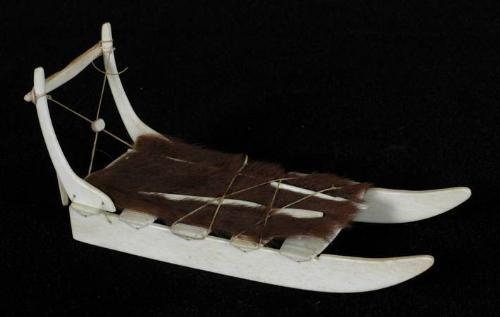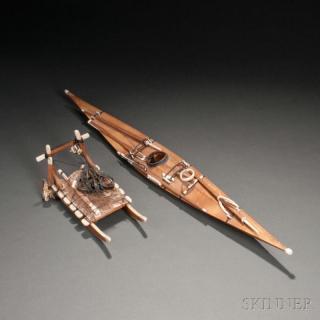The first image is the image on the left, the second image is the image on the right. Assess this claim about the two images: "The sled in the left image is facing right.". Correct or not? Answer yes or no. Yes. 